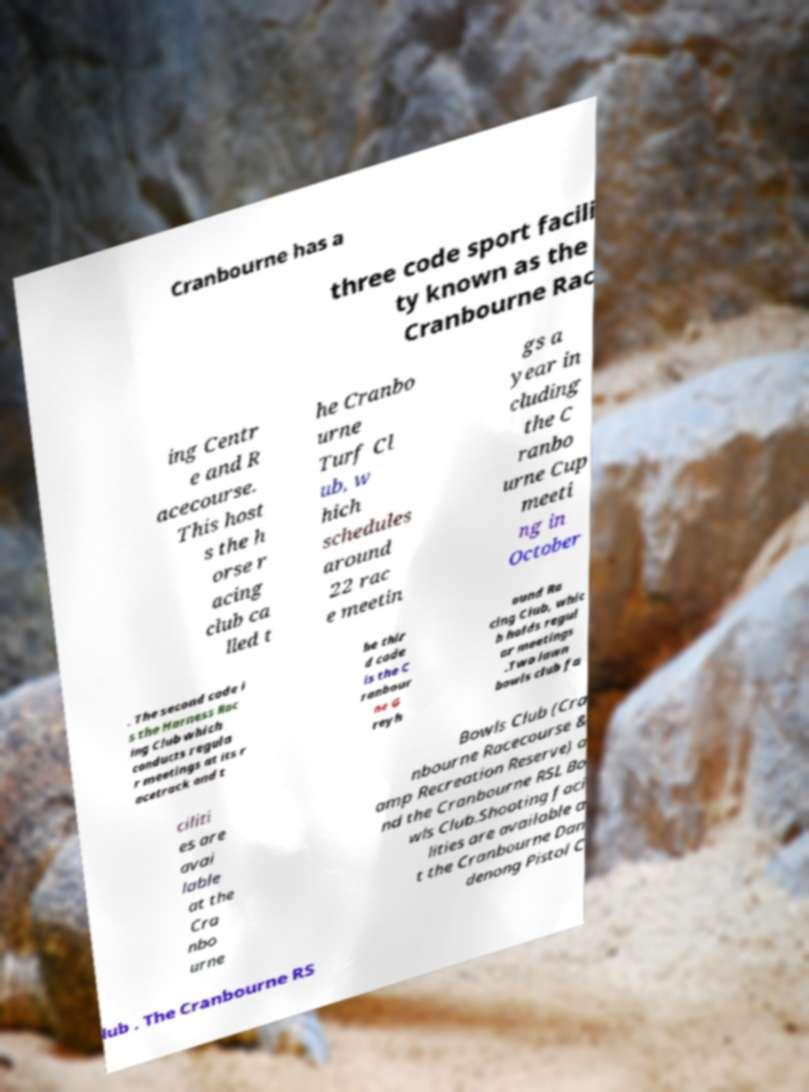Please identify and transcribe the text found in this image. Cranbourne has a three code sport facili ty known as the Cranbourne Rac ing Centr e and R acecourse. This host s the h orse r acing club ca lled t he Cranbo urne Turf Cl ub, w hich schedules around 22 rac e meetin gs a year in cluding the C ranbo urne Cup meeti ng in October . The second code i s the Harness Rac ing Club which conducts regula r meetings at its r acetrack and t he thir d code is the C ranbour ne G reyh ound Ra cing Club, whic h holds regul ar meetings .Two lawn bowls club fa ciliti es are avai lable at the Cra nbo urne Bowls Club (Cra nbourne Racecourse & amp Recreation Reserve) a nd the Cranbourne RSL Bo wls Club.Shooting faci lities are available a t the Cranbourne Dan denong Pistol C lub . The Cranbourne RS 